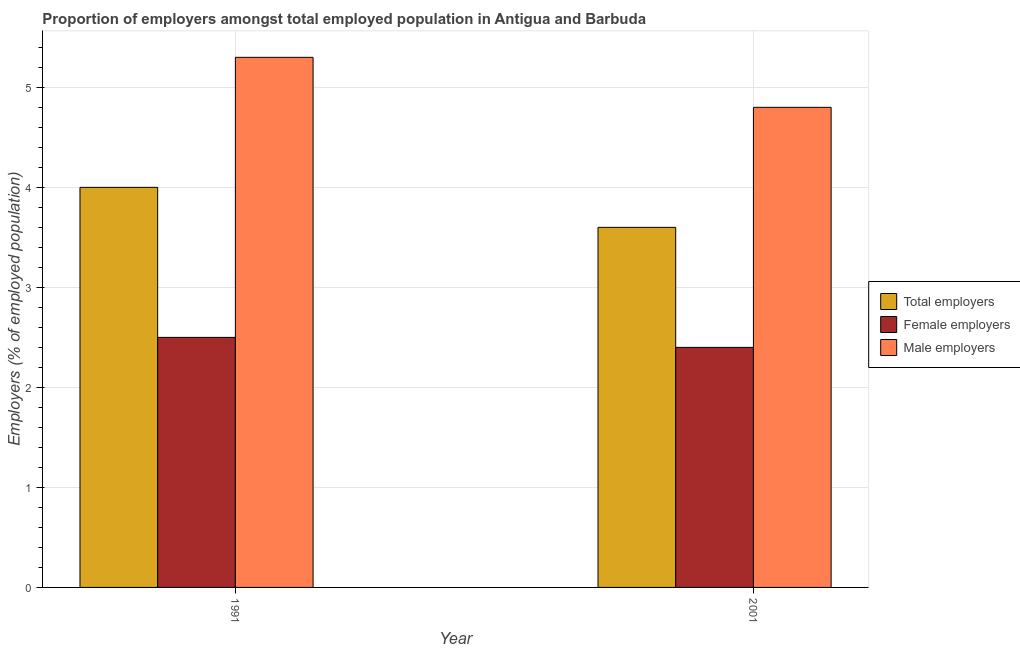How many different coloured bars are there?
Your response must be concise. 3. How many groups of bars are there?
Provide a succinct answer. 2. Are the number of bars per tick equal to the number of legend labels?
Offer a very short reply. Yes. How many bars are there on the 1st tick from the right?
Provide a succinct answer. 3. What is the label of the 2nd group of bars from the left?
Keep it short and to the point. 2001. In how many cases, is the number of bars for a given year not equal to the number of legend labels?
Offer a very short reply. 0. What is the percentage of female employers in 2001?
Provide a short and direct response. 2.4. Across all years, what is the maximum percentage of male employers?
Your answer should be compact. 5.3. Across all years, what is the minimum percentage of male employers?
Ensure brevity in your answer.  4.8. In which year was the percentage of female employers minimum?
Provide a succinct answer. 2001. What is the total percentage of male employers in the graph?
Offer a terse response. 10.1. What is the difference between the percentage of female employers in 1991 and that in 2001?
Ensure brevity in your answer.  0.1. What is the difference between the percentage of female employers in 1991 and the percentage of male employers in 2001?
Make the answer very short. 0.1. What is the average percentage of female employers per year?
Offer a very short reply. 2.45. In the year 2001, what is the difference between the percentage of female employers and percentage of male employers?
Provide a succinct answer. 0. What is the ratio of the percentage of male employers in 1991 to that in 2001?
Your answer should be compact. 1.1. Is the percentage of male employers in 1991 less than that in 2001?
Make the answer very short. No. In how many years, is the percentage of female employers greater than the average percentage of female employers taken over all years?
Offer a terse response. 1. What does the 3rd bar from the left in 1991 represents?
Your response must be concise. Male employers. What does the 3rd bar from the right in 2001 represents?
Provide a short and direct response. Total employers. Are all the bars in the graph horizontal?
Your answer should be compact. No. How many years are there in the graph?
Your answer should be compact. 2. What is the difference between two consecutive major ticks on the Y-axis?
Your response must be concise. 1. Does the graph contain any zero values?
Your answer should be very brief. No. Where does the legend appear in the graph?
Offer a terse response. Center right. How are the legend labels stacked?
Offer a very short reply. Vertical. What is the title of the graph?
Your answer should be compact. Proportion of employers amongst total employed population in Antigua and Barbuda. Does "Male employers" appear as one of the legend labels in the graph?
Your answer should be very brief. Yes. What is the label or title of the X-axis?
Make the answer very short. Year. What is the label or title of the Y-axis?
Make the answer very short. Employers (% of employed population). What is the Employers (% of employed population) of Total employers in 1991?
Provide a succinct answer. 4. What is the Employers (% of employed population) in Male employers in 1991?
Your response must be concise. 5.3. What is the Employers (% of employed population) of Total employers in 2001?
Provide a succinct answer. 3.6. What is the Employers (% of employed population) of Female employers in 2001?
Make the answer very short. 2.4. What is the Employers (% of employed population) in Male employers in 2001?
Your answer should be very brief. 4.8. Across all years, what is the maximum Employers (% of employed population) in Total employers?
Offer a terse response. 4. Across all years, what is the maximum Employers (% of employed population) in Female employers?
Your answer should be compact. 2.5. Across all years, what is the maximum Employers (% of employed population) in Male employers?
Offer a terse response. 5.3. Across all years, what is the minimum Employers (% of employed population) of Total employers?
Provide a succinct answer. 3.6. Across all years, what is the minimum Employers (% of employed population) in Female employers?
Provide a succinct answer. 2.4. Across all years, what is the minimum Employers (% of employed population) of Male employers?
Your response must be concise. 4.8. What is the total Employers (% of employed population) in Female employers in the graph?
Offer a very short reply. 4.9. What is the total Employers (% of employed population) in Male employers in the graph?
Give a very brief answer. 10.1. What is the difference between the Employers (% of employed population) in Total employers in 1991 and the Employers (% of employed population) in Female employers in 2001?
Offer a very short reply. 1.6. What is the average Employers (% of employed population) of Total employers per year?
Your answer should be very brief. 3.8. What is the average Employers (% of employed population) of Female employers per year?
Your response must be concise. 2.45. What is the average Employers (% of employed population) in Male employers per year?
Keep it short and to the point. 5.05. In the year 1991, what is the difference between the Employers (% of employed population) of Total employers and Employers (% of employed population) of Female employers?
Offer a very short reply. 1.5. In the year 1991, what is the difference between the Employers (% of employed population) in Total employers and Employers (% of employed population) in Male employers?
Provide a succinct answer. -1.3. In the year 1991, what is the difference between the Employers (% of employed population) in Female employers and Employers (% of employed population) in Male employers?
Ensure brevity in your answer.  -2.8. In the year 2001, what is the difference between the Employers (% of employed population) of Total employers and Employers (% of employed population) of Male employers?
Keep it short and to the point. -1.2. What is the ratio of the Employers (% of employed population) in Total employers in 1991 to that in 2001?
Ensure brevity in your answer.  1.11. What is the ratio of the Employers (% of employed population) in Female employers in 1991 to that in 2001?
Offer a very short reply. 1.04. What is the ratio of the Employers (% of employed population) of Male employers in 1991 to that in 2001?
Your answer should be very brief. 1.1. What is the difference between the highest and the second highest Employers (% of employed population) in Total employers?
Your answer should be compact. 0.4. What is the difference between the highest and the second highest Employers (% of employed population) in Female employers?
Ensure brevity in your answer.  0.1. What is the difference between the highest and the lowest Employers (% of employed population) of Total employers?
Offer a terse response. 0.4. 